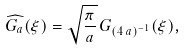Convert formula to latex. <formula><loc_0><loc_0><loc_500><loc_500>\widehat { G _ { a } } ( \xi ) = \sqrt { \frac { \pi } { a } } \, G _ { ( 4 \, a ) ^ { - 1 } } ( \xi ) ,</formula> 